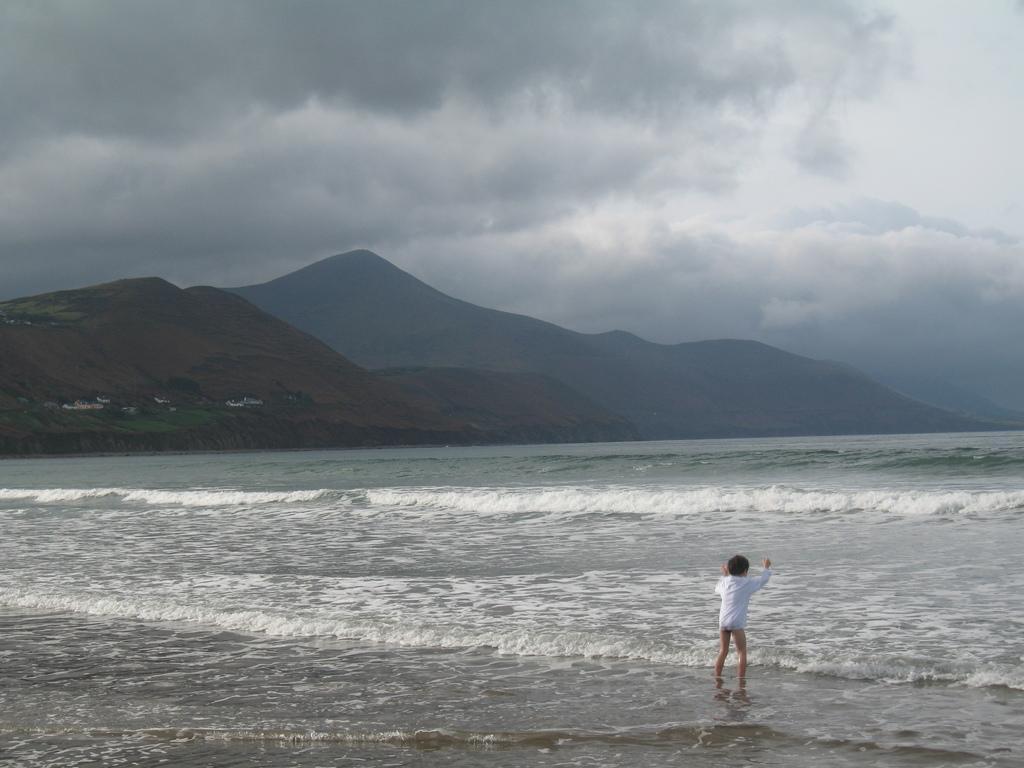In one or two sentences, can you explain what this image depicts? In this picture I can see a person standing in front and I can see the water. In the background I can see the mountains and the cloudy sky. 